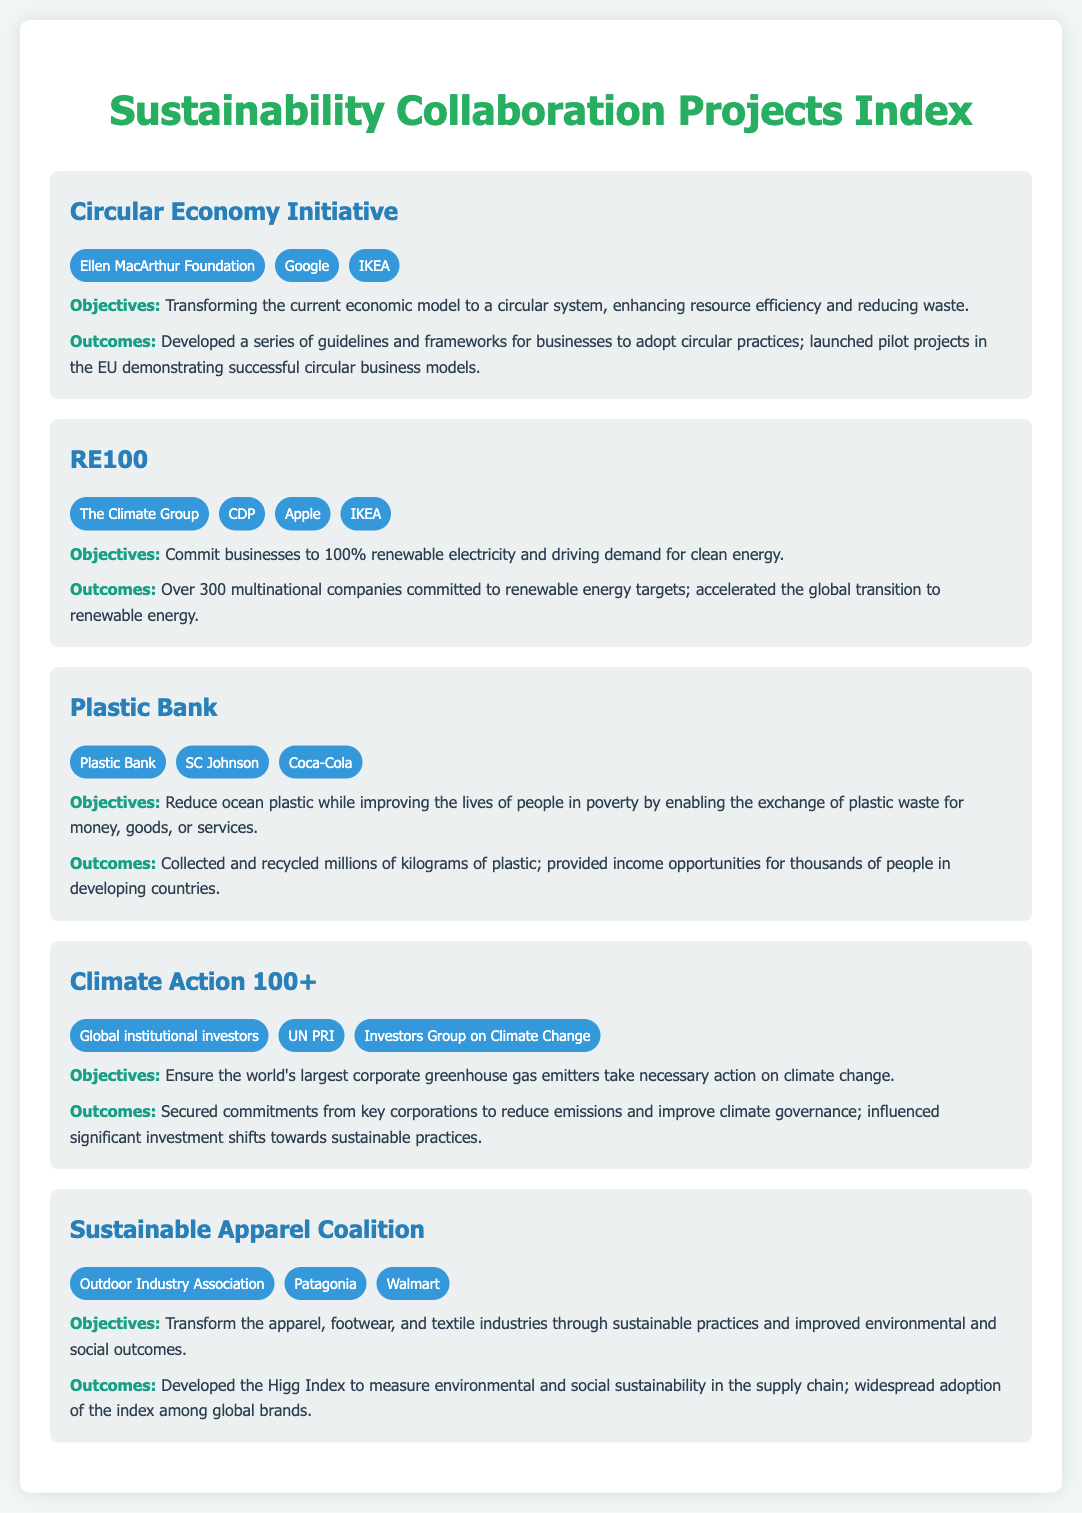What is the name of the initiative focused on a circular economy? The name of the initiative is listed in the document under the projects section.
Answer: Circular Economy Initiative Which partner is involved in the RE100 project? The document shows the partners associated with the RE100 project.
Answer: The Climate Group What is the primary objective of the Plastic Bank? The objectives of the Plastic Bank are detailed in the project description.
Answer: Reduce ocean plastic while improving the lives of people in poverty How many multinational companies have committed to renewable energy targets under RE100? The outcomes section for the RE100 project mentions the number of companies that committed.
Answer: Over 300 What sustainable index was developed by the Sustainable Apparel Coalition? The document states the specific index associated with the Sustainable Apparel Coalition.
Answer: Higg Index What outcome resulted from the Climate Action 100+ initiative? The document describes key outcomes achieved through this initiative.
Answer: Secured commitments from key corporations to reduce emissions Which two companies are partners in the Circular Economy Initiative? The document lists multiple partners for this initiative.
Answer: Ellen MacArthur Foundation, Google What does the Plastic Bank exchange plastic waste for? The objectives section describes the benefits provided by Plastic Bank.
Answer: Money, goods, or services 